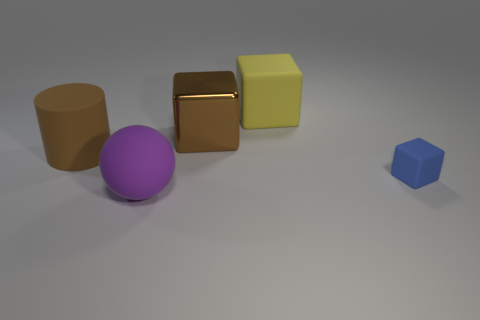Subtract all large matte blocks. How many blocks are left? 2 Add 3 shiny cubes. How many objects exist? 8 Subtract all blue blocks. How many blocks are left? 2 Subtract all cubes. How many objects are left? 2 Subtract 1 cubes. How many cubes are left? 2 Add 1 small blue matte things. How many small blue matte things are left? 2 Add 4 large matte cylinders. How many large matte cylinders exist? 5 Subtract 0 red cubes. How many objects are left? 5 Subtract all yellow cylinders. Subtract all brown balls. How many cylinders are left? 1 Subtract all green cubes. How many green spheres are left? 0 